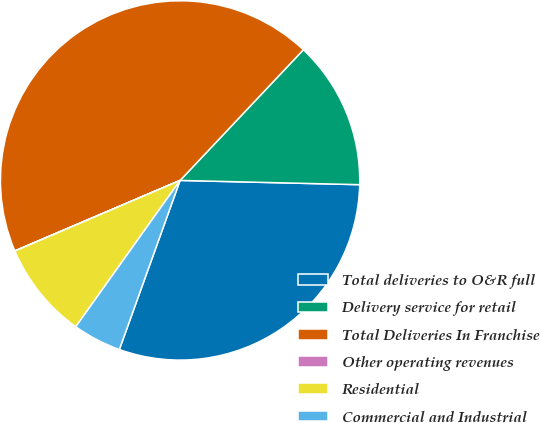Convert chart to OTSL. <chart><loc_0><loc_0><loc_500><loc_500><pie_chart><fcel>Total deliveries to O&R full<fcel>Delivery service for retail<fcel>Total Deliveries In Franchise<fcel>Other operating revenues<fcel>Residential<fcel>Commercial and Industrial<nl><fcel>30.11%<fcel>13.34%<fcel>43.45%<fcel>0.02%<fcel>8.71%<fcel>4.37%<nl></chart> 